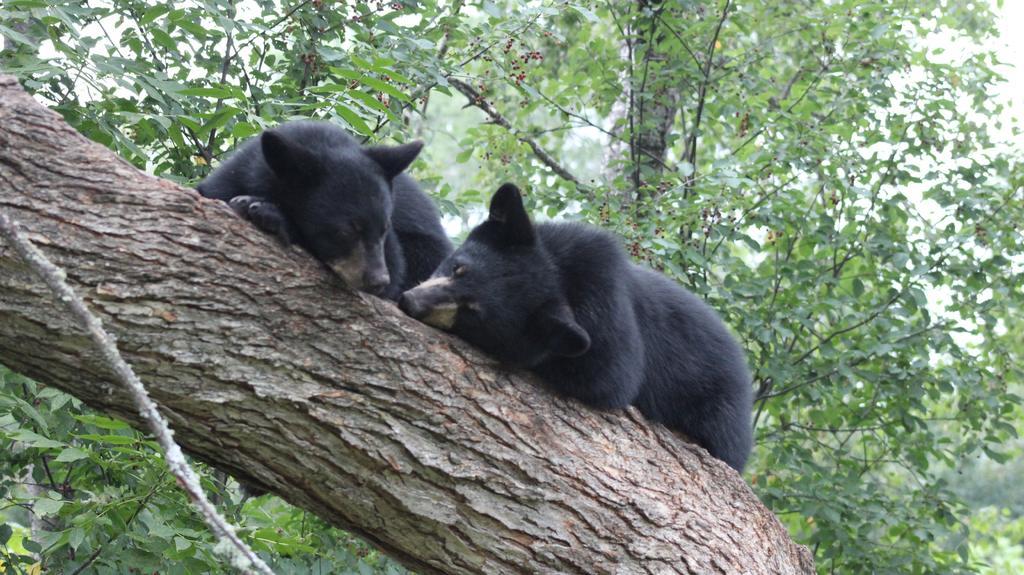Describe this image in one or two sentences. In the foreground of this image, there are two black bears on the tree trunk. In the background, there trees. 